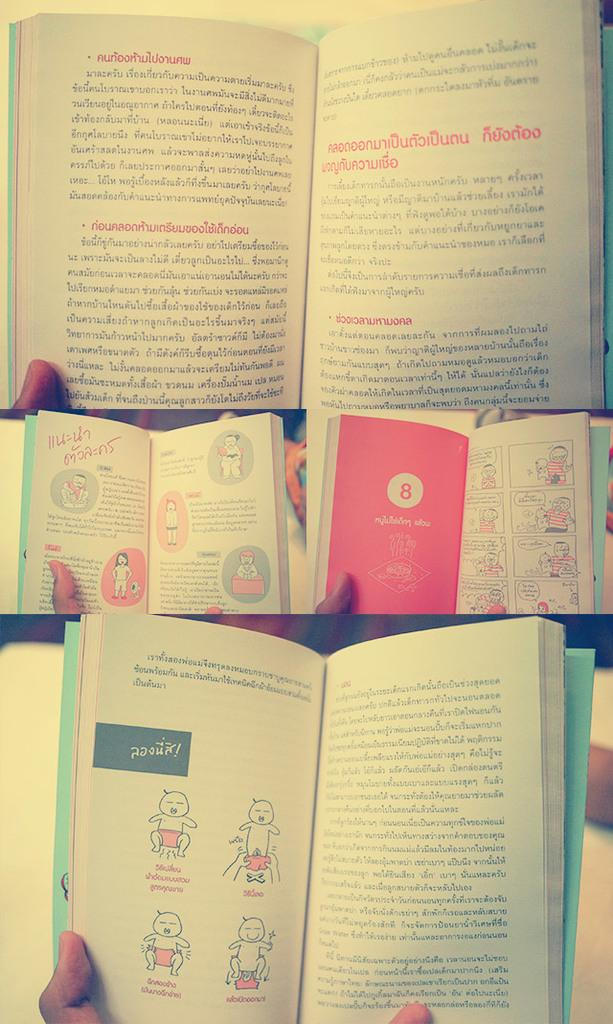<image>
Summarize the visual content of the image. A red page with the number 8 in a white circle is among other books open with a foreign language. 